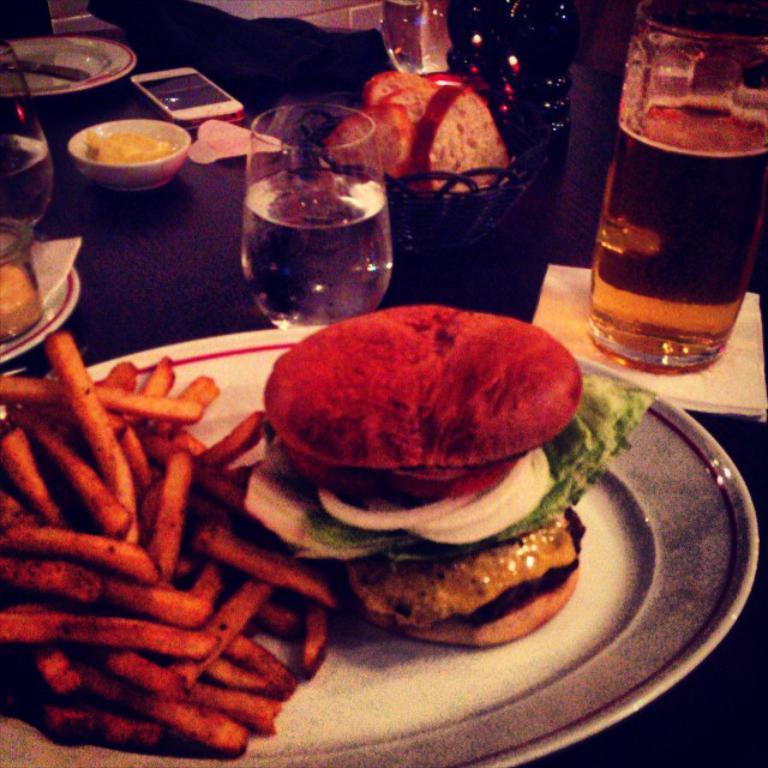Describe this image in one or two sentences. In this image on the table there is a plate and on top of the plate there is a burger, french fries. Beside the plate there is a glass, mobile and a bowl with bread slices. 